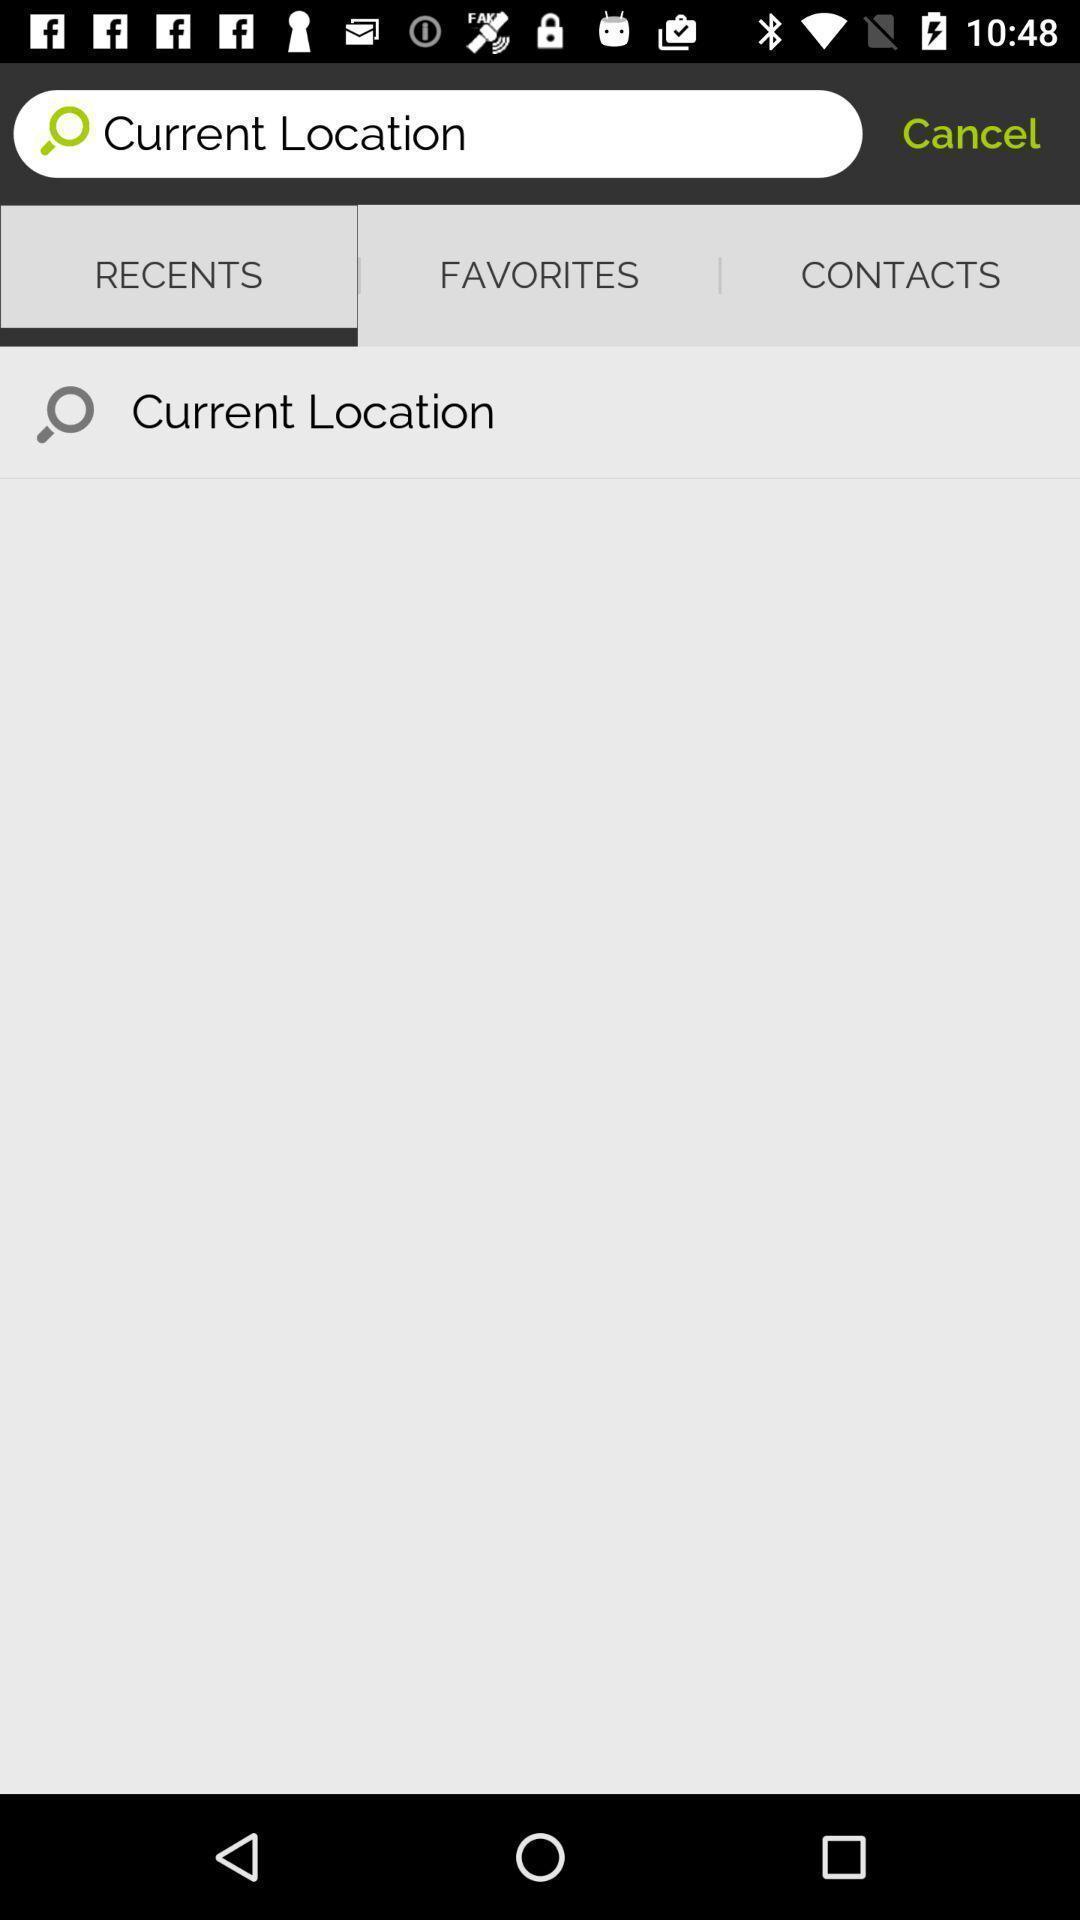Provide a detailed account of this screenshot. Search page for searching current location. 